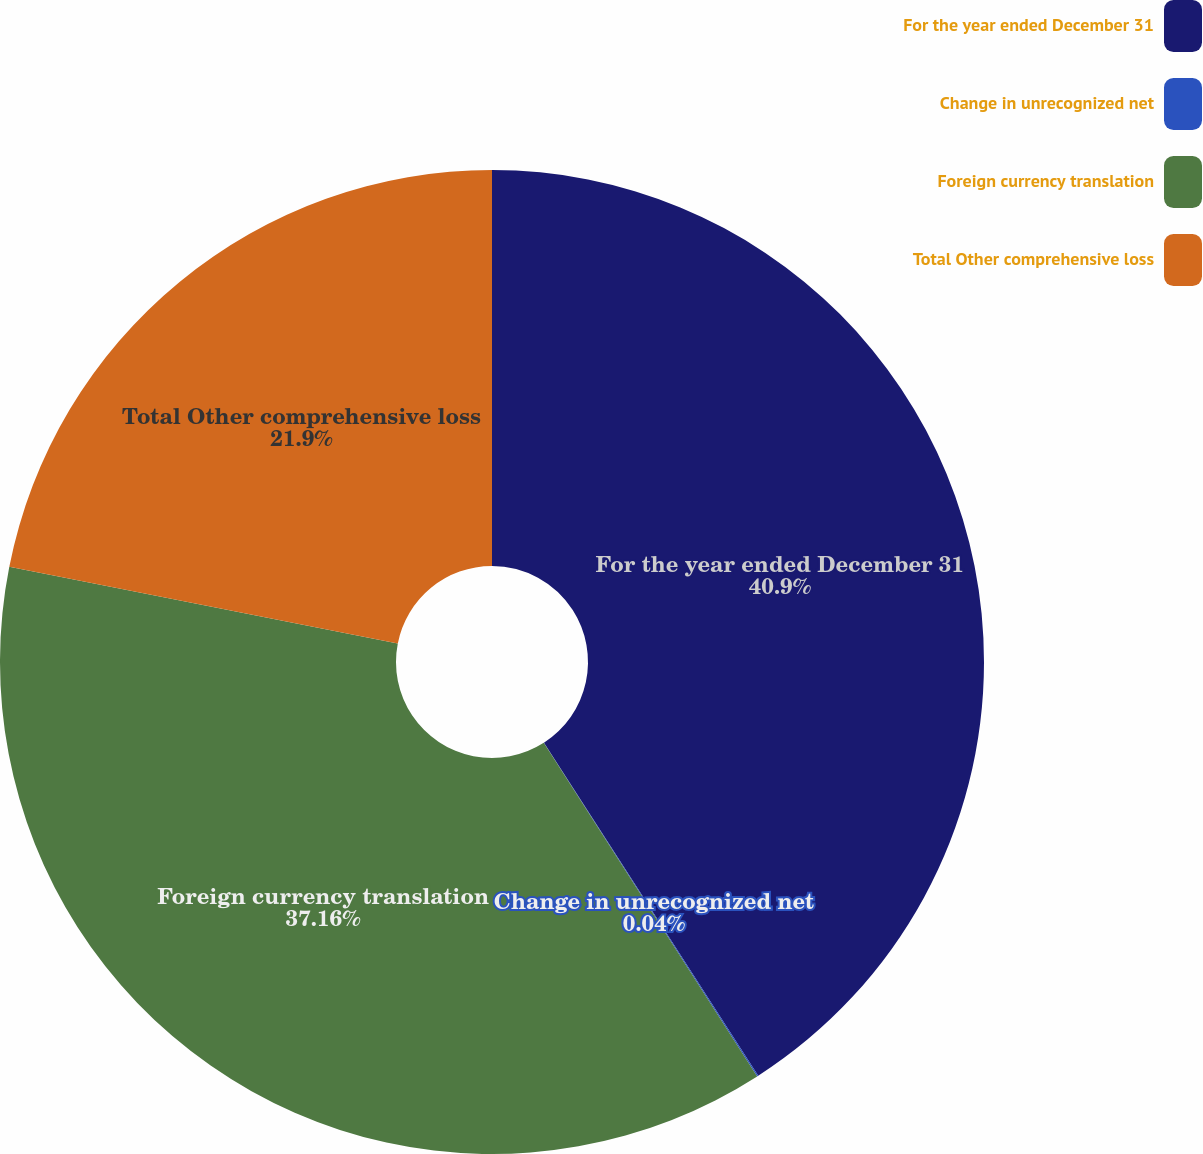<chart> <loc_0><loc_0><loc_500><loc_500><pie_chart><fcel>For the year ended December 31<fcel>Change in unrecognized net<fcel>Foreign currency translation<fcel>Total Other comprehensive loss<nl><fcel>40.9%<fcel>0.04%<fcel>37.16%<fcel>21.9%<nl></chart> 